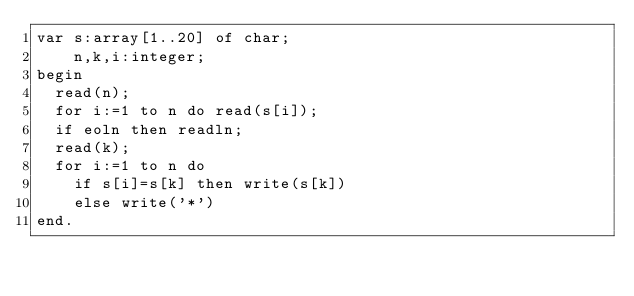<code> <loc_0><loc_0><loc_500><loc_500><_Pascal_>var s:array[1..20] of char;
    n,k,i:integer;
begin
  read(n);
  for i:=1 to n do read(s[i]);
  if eoln then readln;
  read(k);
  for i:=1 to n do 
    if s[i]=s[k] then write(s[k])
    else write('*')
end.
</code> 